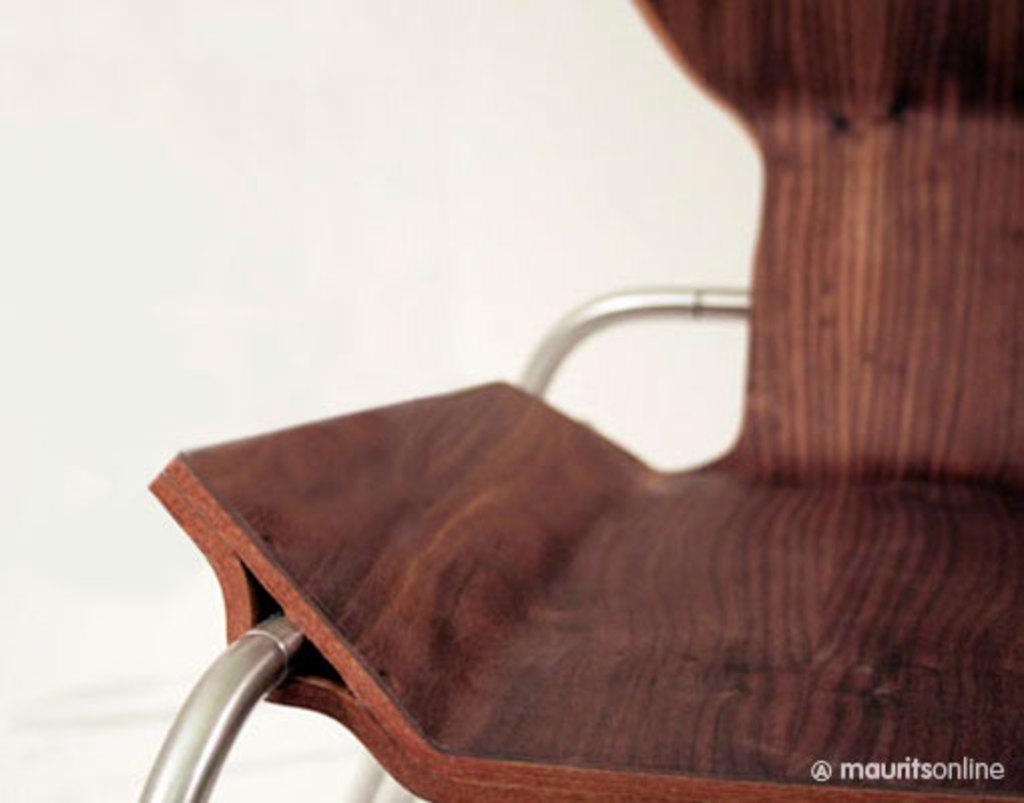Describe this image in one or two sentences. In front of the image there is a chair. Behind the chair there is a wall. There is some text at the bottom of the image. 